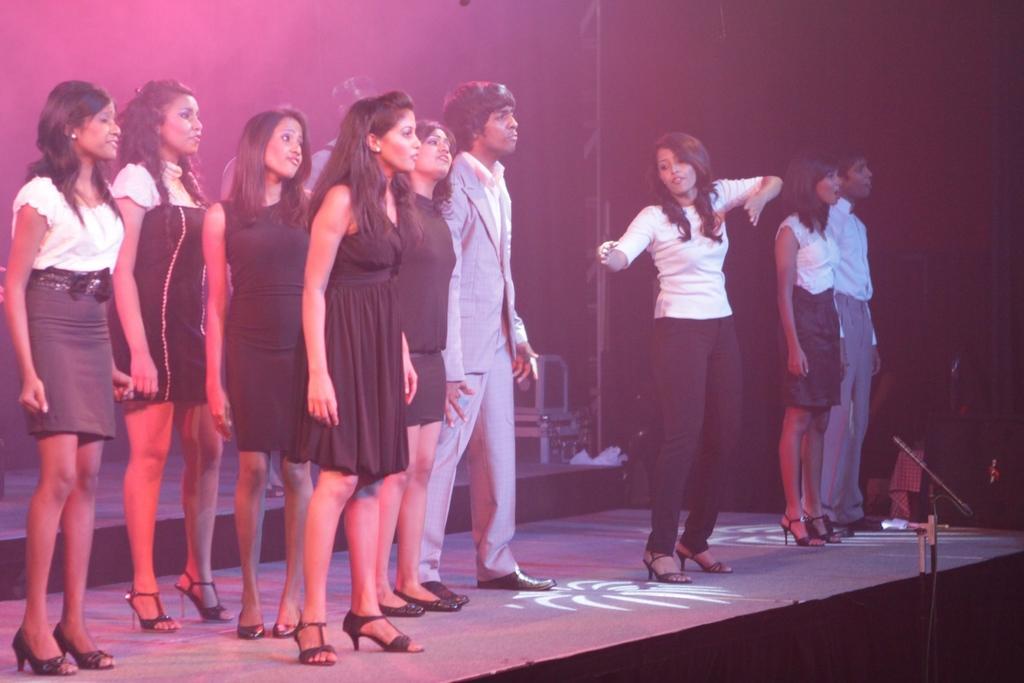How would you summarize this image in a sentence or two? In this image few persons are standing on the stage. Left side few women are standing on the stage. Beside them a person wearing a suit. A woman wearing a white suit is standing on the stage. Right side there is a person wearing a white shirt is standing beside to a woman wearing white top. Before the stage there is a mike stand. Behind the women there are few persons standing. 